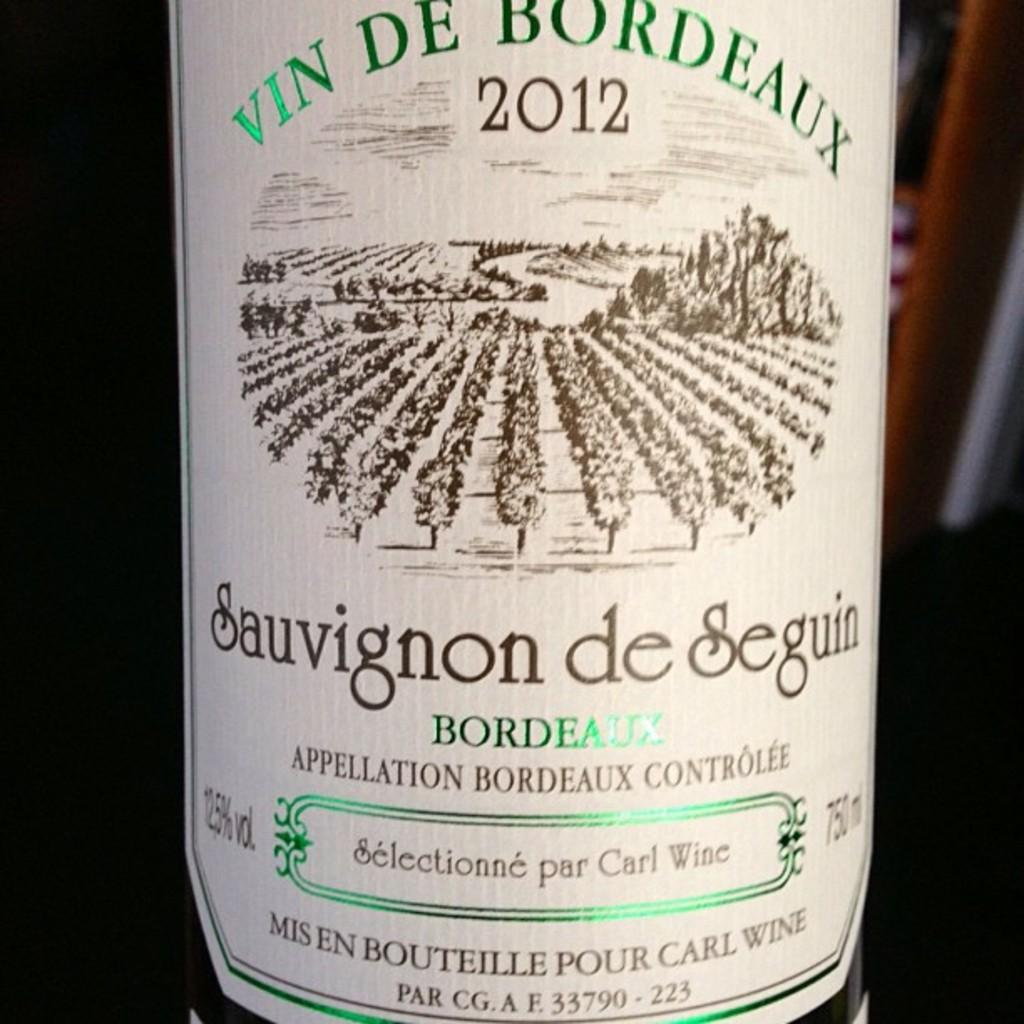<image>
Give a short and clear explanation of the subsequent image. A wine label that is off white and has green and brown letters and says 2012 at the top. 